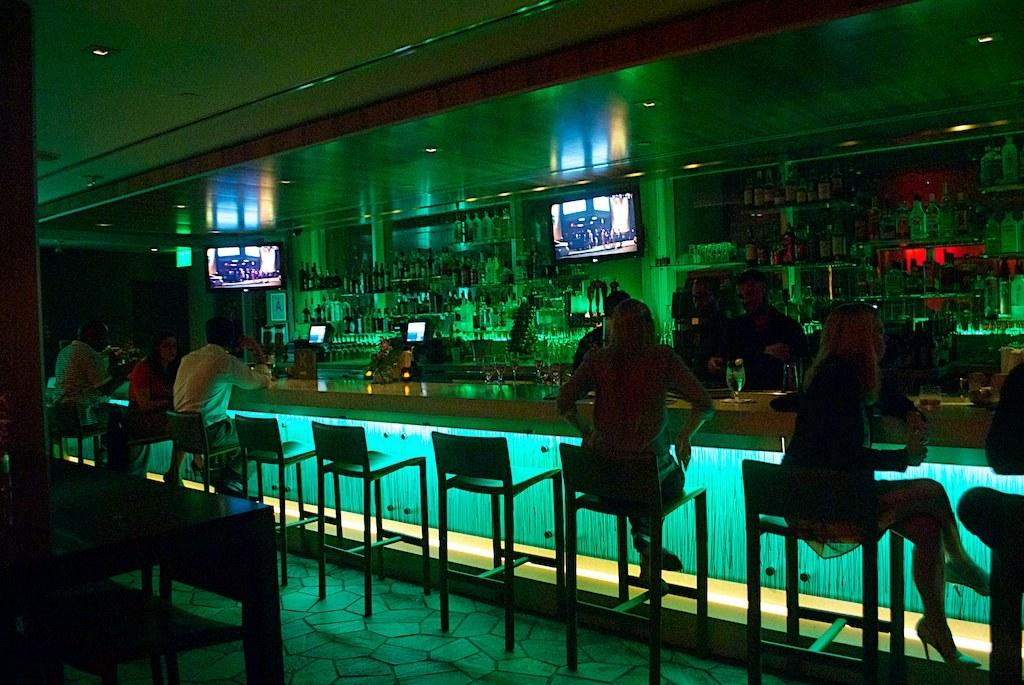How many people are in the image? There is a group of people in the image, but the exact number is not specified. What are the people doing in the image? The people are sitting on chairs in the image. Where are the chairs located in relation to the table? The chairs are in front of a table in the image. What can be seen on the table in the image? The presence of bottles suggests that there might be drinks or other items on the table. What is on the wall in the image? There are TVs on the wall in the image. Can you see any goldfish swimming in the lake in the image? There is no lake or goldfish present in the image. 